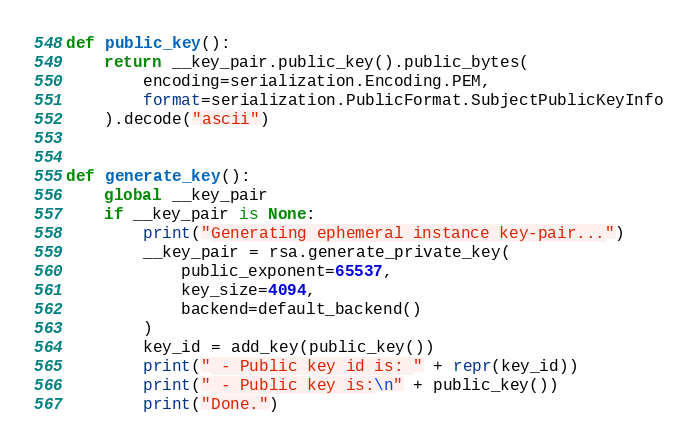Convert code to text. <code><loc_0><loc_0><loc_500><loc_500><_Python_>

def public_key():
    return __key_pair.public_key().public_bytes(
        encoding=serialization.Encoding.PEM,
        format=serialization.PublicFormat.SubjectPublicKeyInfo
    ).decode("ascii")


def generate_key():
    global __key_pair
    if __key_pair is None:
        print("Generating ephemeral instance key-pair...")
        __key_pair = rsa.generate_private_key(
            public_exponent=65537,
            key_size=4094,
            backend=default_backend()
        )
        key_id = add_key(public_key())
        print(" - Public key id is: " + repr(key_id))
        print(" - Public key is:\n" + public_key())
        print("Done.")
</code> 